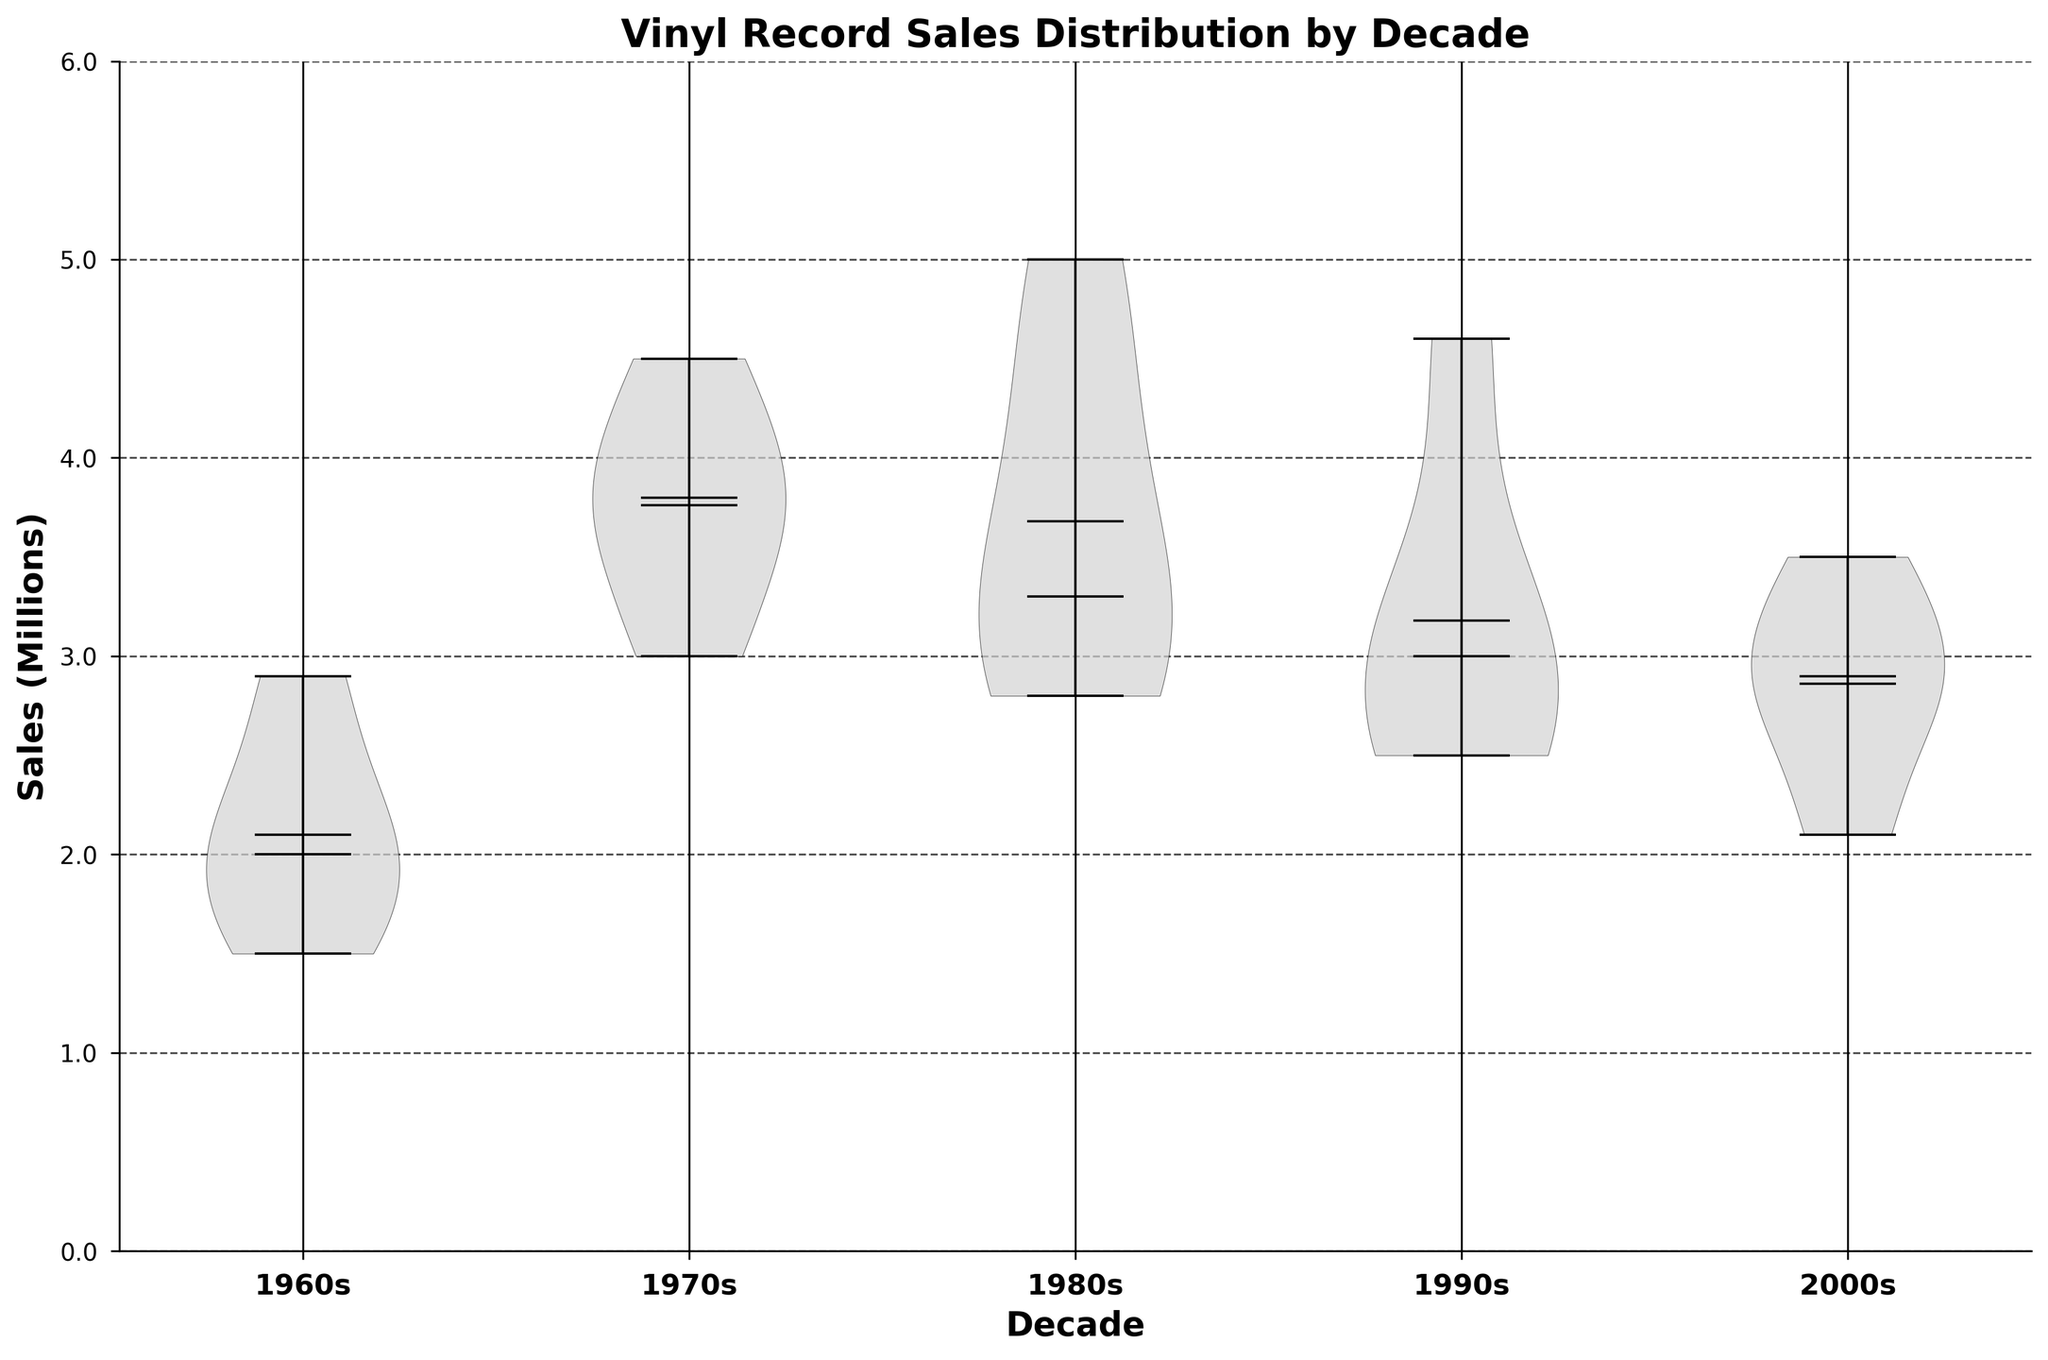What is the title of the figure? The title of the figure is typically positioned at the top center. In this figure, it says "Vinyl Record Sales Distribution by Decade."
Answer: Vinyl Record Sales Distribution by Decade What do the vertical axis represent? The vertical axis represents the sales in millions. The y-ticks are labeled as '0.0', '1.0', '2.0', '3.0', '4.0', '5.0', and '6.0'.
Answer: Sales (Millions) Which decade has the highest mean sales? To identify the decade with the highest mean sales, look at the mean indicators (solid lines within the violins). The 1980s' mean line appears the highest among all decades.
Answer: 1980s How does the distribution of sales in the 1970s compare to that in the 2000s? By comparing the width and spread of the violin plots, we can see that the 1970s have a wider distribution indicating greater variability in sales compared to the 2000s. The 1970s also have a higher median.
Answer: The 1970s have greater variability and a higher median compared to the 2000s What is the median sales value in the 1990s? The median sales is represented by the dashed line within the violin plot. For the 1990s, it cuts across just below the 3000000 mark, around 2900000.
Answer: Around 2900000 Which decade shows the least variability in sales? The decade with the least variability in sales will have the narrowest violin plot. The 1980s and 2000s both have relatively narrow distributions, but the 2000s show a bit less variability.
Answer: 2000s What can be inferred about the number of records released in each decade? Wider violin plots indicate more data points or records. Therefore, the 1980s and 1970s seem to have more records compared to other decades due to the wider spread of their violins.
Answer: 1980s and 1970s have more records Which decade has the least median sales and which has the highest median sales? By evaluating the dashed lines (medians), the 2000s have the lowest median below 3000000, while the 1980s have the highest median, above 3500000.
Answer: Least: 2000s, Highest: 1980s What does the presence of vertical lines at both ends of the violins represent? The vertical lines at both ends of the violins represent the range or the minimum and maximum values of sales within each decade.
Answer: Range of sales How do the extreme values (minimum and maximum) in the 1960s compare with those in the 1990s? The endpoints of the vertical lines help in comparison. Both the 1960s and the 1990s have similar maximum values around 5000000, but the 1990s have a slightly higher minimum value compared to the 1960s.
Answer: Similar maximums around 5000000, 1990s have a higher minimum 